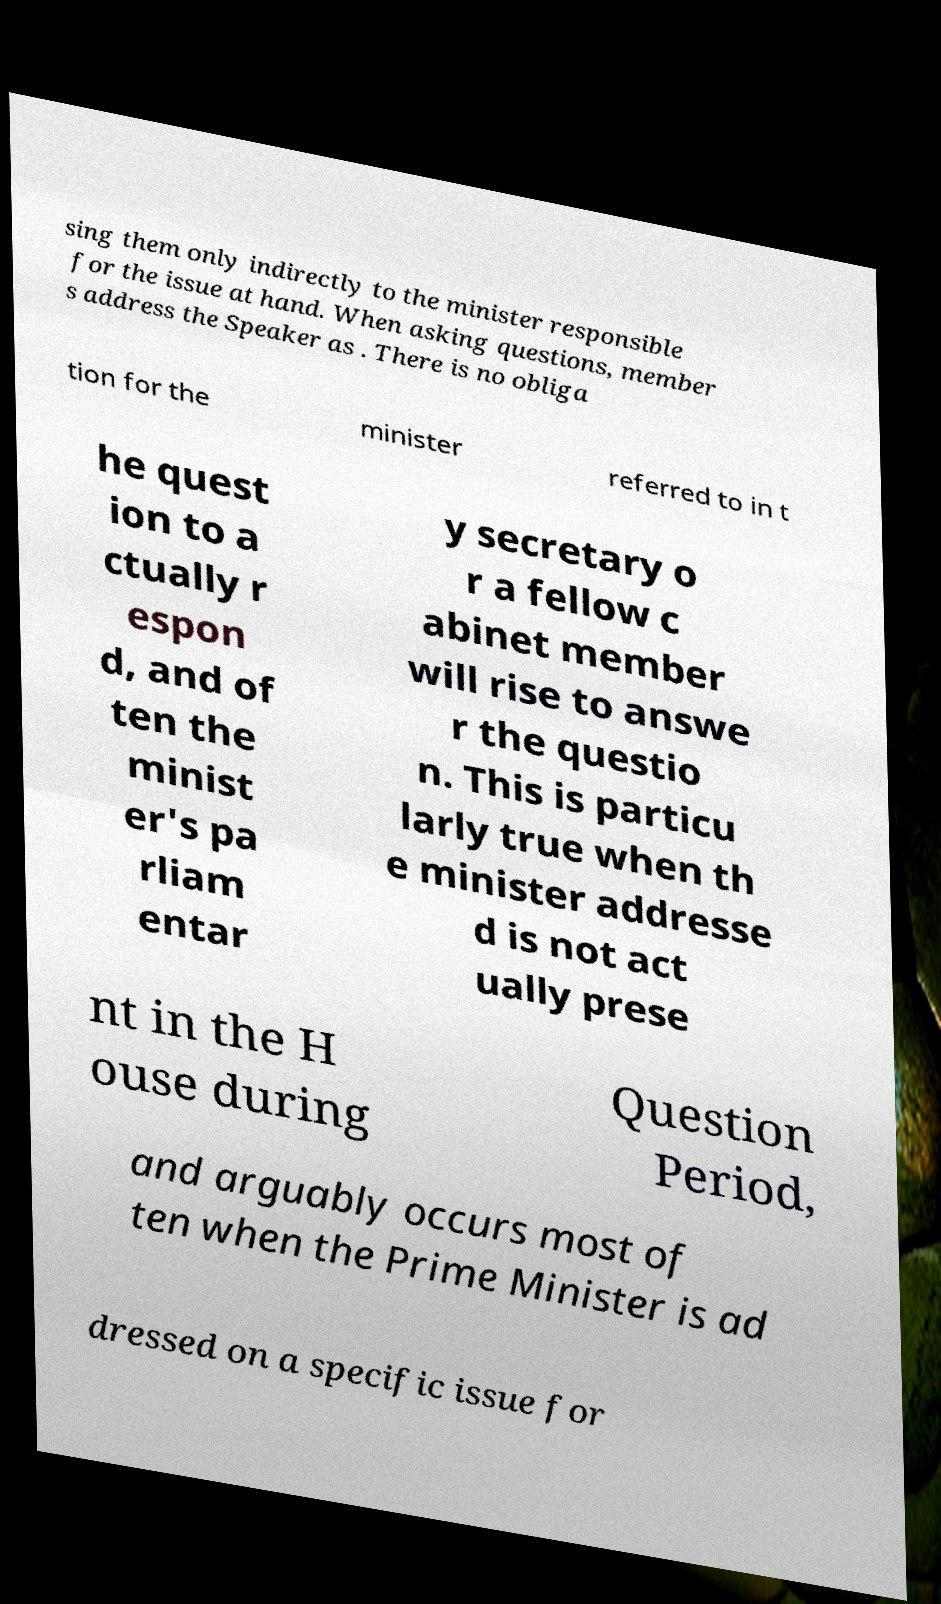Could you extract and type out the text from this image? sing them only indirectly to the minister responsible for the issue at hand. When asking questions, member s address the Speaker as . There is no obliga tion for the minister referred to in t he quest ion to a ctually r espon d, and of ten the minist er's pa rliam entar y secretary o r a fellow c abinet member will rise to answe r the questio n. This is particu larly true when th e minister addresse d is not act ually prese nt in the H ouse during Question Period, and arguably occurs most of ten when the Prime Minister is ad dressed on a specific issue for 